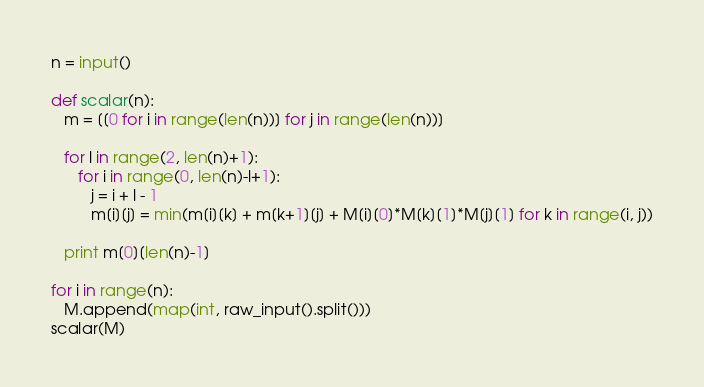Convert code to text. <code><loc_0><loc_0><loc_500><loc_500><_Python_>n = input()

def scalar(n):
   m = [[0 for i in range(len(n))] for j in range(len(n))]

   for l in range(2, len(n)+1):
      for i in range(0, len(n)-l+1):
         j = i + l - 1
         m[i][j] = min(m[i][k] + m[k+1][j] + M[i][0]*M[k][1]*M[j][1] for k in range(i, j))

   print m[0][len(n)-1]

for i in range(n):
   M.append(map(int, raw_input().split()))
scalar(M)</code> 